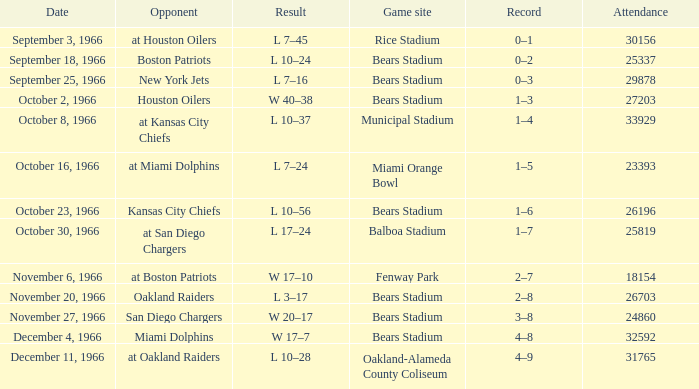On october 16, 1966, what was the venue for the game? Miami Orange Bowl. 